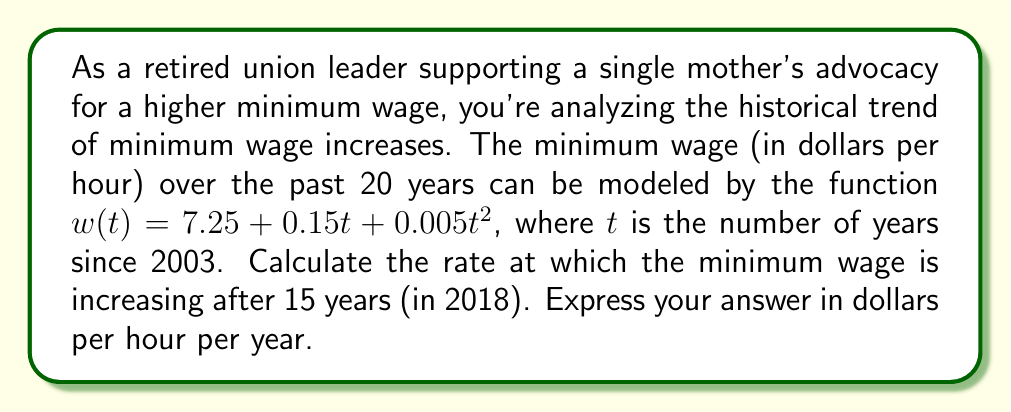Teach me how to tackle this problem. To solve this problem, we need to find the derivative of the given function and then evaluate it at $t = 15$. Here's the step-by-step process:

1. Given function: $w(t) = 7.25 + 0.15t + 0.005t^2$

2. To find the rate of change, we need to calculate the first derivative:
   $$\frac{dw}{dt} = \frac{d}{dt}(7.25 + 0.15t + 0.005t^2)$$
   $$\frac{dw}{dt} = 0 + 0.15 + 0.01t$$
   $$\frac{dw}{dt} = 0.15 + 0.01t$$

3. Now we need to evaluate this derivative at $t = 15$:
   $$\left.\frac{dw}{dt}\right|_{t=15} = 0.15 + 0.01(15)$$
   $$\left.\frac{dw}{dt}\right|_{t=15} = 0.15 + 0.15$$
   $$\left.\frac{dw}{dt}\right|_{t=15} = 0.30$$

4. Interpret the result: The rate of change of the minimum wage after 15 years (in 2018) is $0.30 dollars per hour per year.

This means that in 2018, the minimum wage was increasing at a rate of 30 cents per hour each year, according to the given model.
Answer: $0.30 dollars per hour per year 